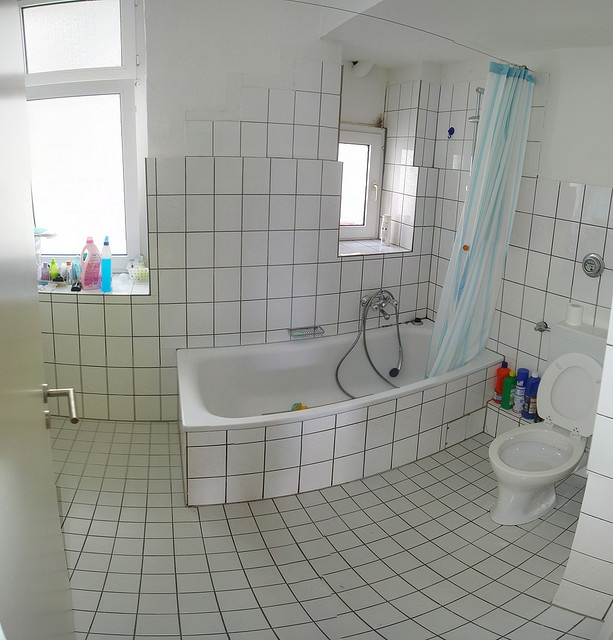Describe the objects in this image and their specific colors. I can see toilet in gray, darkgray, and lightgray tones, bottle in gray, navy, and black tones, bottle in gray, lightblue, lightgray, and darkgray tones, bottle in gray, darkgreen, and olive tones, and bottle in gray, maroon, and black tones in this image. 